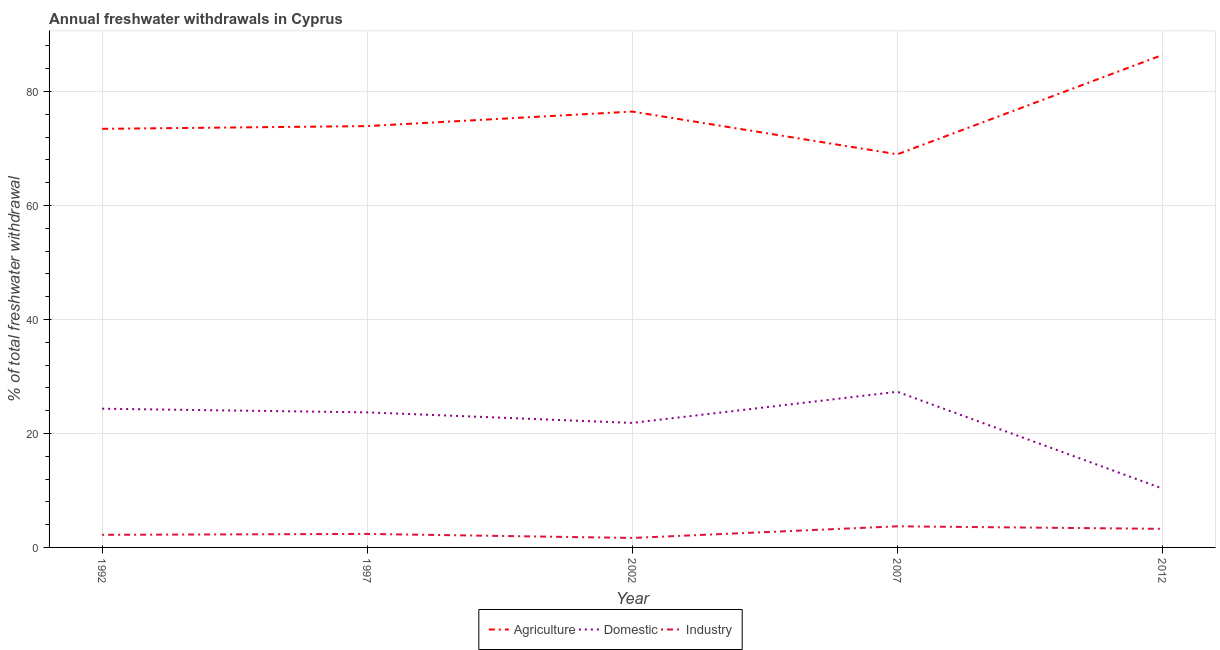How many different coloured lines are there?
Your answer should be very brief. 3. Does the line corresponding to percentage of freshwater withdrawal for domestic purposes intersect with the line corresponding to percentage of freshwater withdrawal for industry?
Give a very brief answer. No. Is the number of lines equal to the number of legend labels?
Your answer should be very brief. Yes. What is the percentage of freshwater withdrawal for industry in 2012?
Provide a short and direct response. 3.26. Across all years, what is the maximum percentage of freshwater withdrawal for domestic purposes?
Ensure brevity in your answer.  27.31. Across all years, what is the minimum percentage of freshwater withdrawal for industry?
Your answer should be very brief. 1.66. In which year was the percentage of freshwater withdrawal for domestic purposes maximum?
Your response must be concise. 2007. In which year was the percentage of freshwater withdrawal for industry minimum?
Make the answer very short. 2002. What is the total percentage of freshwater withdrawal for industry in the graph?
Your answer should be very brief. 13.21. What is the difference between the percentage of freshwater withdrawal for agriculture in 2007 and the percentage of freshwater withdrawal for industry in 2012?
Your answer should be very brief. 65.72. What is the average percentage of freshwater withdrawal for domestic purposes per year?
Provide a succinct answer. 21.51. In the year 1997, what is the difference between the percentage of freshwater withdrawal for agriculture and percentage of freshwater withdrawal for industry?
Offer a very short reply. 71.56. What is the ratio of the percentage of freshwater withdrawal for domestic purposes in 1997 to that in 2012?
Provide a succinct answer. 2.29. Is the percentage of freshwater withdrawal for agriculture in 1992 less than that in 2012?
Make the answer very short. Yes. Is the difference between the percentage of freshwater withdrawal for industry in 1997 and 2012 greater than the difference between the percentage of freshwater withdrawal for agriculture in 1997 and 2012?
Your answer should be very brief. Yes. What is the difference between the highest and the second highest percentage of freshwater withdrawal for industry?
Ensure brevity in your answer.  0.44. What is the difference between the highest and the lowest percentage of freshwater withdrawal for domestic purposes?
Your answer should be compact. 16.98. In how many years, is the percentage of freshwater withdrawal for domestic purposes greater than the average percentage of freshwater withdrawal for domestic purposes taken over all years?
Your response must be concise. 4. Does the percentage of freshwater withdrawal for industry monotonically increase over the years?
Provide a succinct answer. No. Is the percentage of freshwater withdrawal for domestic purposes strictly less than the percentage of freshwater withdrawal for agriculture over the years?
Your response must be concise. Yes. How many years are there in the graph?
Make the answer very short. 5. Are the values on the major ticks of Y-axis written in scientific E-notation?
Give a very brief answer. No. Does the graph contain grids?
Ensure brevity in your answer.  Yes. What is the title of the graph?
Give a very brief answer. Annual freshwater withdrawals in Cyprus. Does "Nuclear sources" appear as one of the legend labels in the graph?
Provide a succinct answer. No. What is the label or title of the X-axis?
Provide a short and direct response. Year. What is the label or title of the Y-axis?
Make the answer very short. % of total freshwater withdrawal. What is the % of total freshwater withdrawal of Agriculture in 1992?
Provide a short and direct response. 73.45. What is the % of total freshwater withdrawal of Domestic in 1992?
Your answer should be very brief. 24.34. What is the % of total freshwater withdrawal of Industry in 1992?
Your response must be concise. 2.21. What is the % of total freshwater withdrawal in Agriculture in 1997?
Give a very brief answer. 73.93. What is the % of total freshwater withdrawal in Domestic in 1997?
Your response must be concise. 23.7. What is the % of total freshwater withdrawal in Industry in 1997?
Make the answer very short. 2.37. What is the % of total freshwater withdrawal in Agriculture in 2002?
Provide a succinct answer. 76.48. What is the % of total freshwater withdrawal of Domestic in 2002?
Offer a terse response. 21.85. What is the % of total freshwater withdrawal in Industry in 2002?
Keep it short and to the point. 1.66. What is the % of total freshwater withdrawal in Agriculture in 2007?
Offer a very short reply. 68.98. What is the % of total freshwater withdrawal in Domestic in 2007?
Your answer should be very brief. 27.31. What is the % of total freshwater withdrawal of Industry in 2007?
Offer a terse response. 3.7. What is the % of total freshwater withdrawal in Agriculture in 2012?
Offer a very short reply. 86.41. What is the % of total freshwater withdrawal of Domestic in 2012?
Provide a short and direct response. 10.33. What is the % of total freshwater withdrawal in Industry in 2012?
Keep it short and to the point. 3.26. Across all years, what is the maximum % of total freshwater withdrawal in Agriculture?
Your response must be concise. 86.41. Across all years, what is the maximum % of total freshwater withdrawal in Domestic?
Your response must be concise. 27.31. Across all years, what is the maximum % of total freshwater withdrawal in Industry?
Ensure brevity in your answer.  3.7. Across all years, what is the minimum % of total freshwater withdrawal of Agriculture?
Your answer should be compact. 68.98. Across all years, what is the minimum % of total freshwater withdrawal of Domestic?
Make the answer very short. 10.33. Across all years, what is the minimum % of total freshwater withdrawal of Industry?
Provide a succinct answer. 1.66. What is the total % of total freshwater withdrawal in Agriculture in the graph?
Ensure brevity in your answer.  379.25. What is the total % of total freshwater withdrawal in Domestic in the graph?
Your answer should be very brief. 107.53. What is the total % of total freshwater withdrawal of Industry in the graph?
Give a very brief answer. 13.21. What is the difference between the % of total freshwater withdrawal of Agriculture in 1992 and that in 1997?
Make the answer very short. -0.48. What is the difference between the % of total freshwater withdrawal in Domestic in 1992 and that in 1997?
Your response must be concise. 0.64. What is the difference between the % of total freshwater withdrawal in Industry in 1992 and that in 1997?
Keep it short and to the point. -0.16. What is the difference between the % of total freshwater withdrawal in Agriculture in 1992 and that in 2002?
Offer a terse response. -3.03. What is the difference between the % of total freshwater withdrawal of Domestic in 1992 and that in 2002?
Ensure brevity in your answer.  2.49. What is the difference between the % of total freshwater withdrawal in Industry in 1992 and that in 2002?
Your response must be concise. 0.55. What is the difference between the % of total freshwater withdrawal in Agriculture in 1992 and that in 2007?
Provide a short and direct response. 4.47. What is the difference between the % of total freshwater withdrawal of Domestic in 1992 and that in 2007?
Provide a short and direct response. -2.97. What is the difference between the % of total freshwater withdrawal of Industry in 1992 and that in 2007?
Offer a terse response. -1.49. What is the difference between the % of total freshwater withdrawal in Agriculture in 1992 and that in 2012?
Make the answer very short. -12.96. What is the difference between the % of total freshwater withdrawal in Domestic in 1992 and that in 2012?
Provide a succinct answer. 14.01. What is the difference between the % of total freshwater withdrawal of Industry in 1992 and that in 2012?
Give a very brief answer. -1.05. What is the difference between the % of total freshwater withdrawal in Agriculture in 1997 and that in 2002?
Ensure brevity in your answer.  -2.55. What is the difference between the % of total freshwater withdrawal of Domestic in 1997 and that in 2002?
Offer a terse response. 1.85. What is the difference between the % of total freshwater withdrawal of Industry in 1997 and that in 2002?
Provide a short and direct response. 0.71. What is the difference between the % of total freshwater withdrawal in Agriculture in 1997 and that in 2007?
Give a very brief answer. 4.95. What is the difference between the % of total freshwater withdrawal of Domestic in 1997 and that in 2007?
Your answer should be very brief. -3.61. What is the difference between the % of total freshwater withdrawal in Industry in 1997 and that in 2007?
Make the answer very short. -1.33. What is the difference between the % of total freshwater withdrawal of Agriculture in 1997 and that in 2012?
Give a very brief answer. -12.48. What is the difference between the % of total freshwater withdrawal of Domestic in 1997 and that in 2012?
Your response must be concise. 13.37. What is the difference between the % of total freshwater withdrawal of Industry in 1997 and that in 2012?
Make the answer very short. -0.89. What is the difference between the % of total freshwater withdrawal in Agriculture in 2002 and that in 2007?
Your answer should be very brief. 7.5. What is the difference between the % of total freshwater withdrawal in Domestic in 2002 and that in 2007?
Provide a short and direct response. -5.46. What is the difference between the % of total freshwater withdrawal of Industry in 2002 and that in 2007?
Your response must be concise. -2.04. What is the difference between the % of total freshwater withdrawal of Agriculture in 2002 and that in 2012?
Your answer should be very brief. -9.93. What is the difference between the % of total freshwater withdrawal in Domestic in 2002 and that in 2012?
Ensure brevity in your answer.  11.52. What is the difference between the % of total freshwater withdrawal of Industry in 2002 and that in 2012?
Your response must be concise. -1.6. What is the difference between the % of total freshwater withdrawal of Agriculture in 2007 and that in 2012?
Ensure brevity in your answer.  -17.43. What is the difference between the % of total freshwater withdrawal of Domestic in 2007 and that in 2012?
Keep it short and to the point. 16.98. What is the difference between the % of total freshwater withdrawal in Industry in 2007 and that in 2012?
Provide a short and direct response. 0.44. What is the difference between the % of total freshwater withdrawal of Agriculture in 1992 and the % of total freshwater withdrawal of Domestic in 1997?
Make the answer very short. 49.75. What is the difference between the % of total freshwater withdrawal of Agriculture in 1992 and the % of total freshwater withdrawal of Industry in 1997?
Your response must be concise. 71.08. What is the difference between the % of total freshwater withdrawal of Domestic in 1992 and the % of total freshwater withdrawal of Industry in 1997?
Provide a succinct answer. 21.97. What is the difference between the % of total freshwater withdrawal of Agriculture in 1992 and the % of total freshwater withdrawal of Domestic in 2002?
Give a very brief answer. 51.6. What is the difference between the % of total freshwater withdrawal in Agriculture in 1992 and the % of total freshwater withdrawal in Industry in 2002?
Your answer should be compact. 71.79. What is the difference between the % of total freshwater withdrawal in Domestic in 1992 and the % of total freshwater withdrawal in Industry in 2002?
Your response must be concise. 22.68. What is the difference between the % of total freshwater withdrawal in Agriculture in 1992 and the % of total freshwater withdrawal in Domestic in 2007?
Keep it short and to the point. 46.14. What is the difference between the % of total freshwater withdrawal in Agriculture in 1992 and the % of total freshwater withdrawal in Industry in 2007?
Keep it short and to the point. 69.75. What is the difference between the % of total freshwater withdrawal in Domestic in 1992 and the % of total freshwater withdrawal in Industry in 2007?
Offer a very short reply. 20.64. What is the difference between the % of total freshwater withdrawal in Agriculture in 1992 and the % of total freshwater withdrawal in Domestic in 2012?
Provide a short and direct response. 63.12. What is the difference between the % of total freshwater withdrawal of Agriculture in 1992 and the % of total freshwater withdrawal of Industry in 2012?
Your answer should be compact. 70.19. What is the difference between the % of total freshwater withdrawal of Domestic in 1992 and the % of total freshwater withdrawal of Industry in 2012?
Ensure brevity in your answer.  21.08. What is the difference between the % of total freshwater withdrawal in Agriculture in 1997 and the % of total freshwater withdrawal in Domestic in 2002?
Your answer should be compact. 52.08. What is the difference between the % of total freshwater withdrawal in Agriculture in 1997 and the % of total freshwater withdrawal in Industry in 2002?
Provide a succinct answer. 72.27. What is the difference between the % of total freshwater withdrawal of Domestic in 1997 and the % of total freshwater withdrawal of Industry in 2002?
Make the answer very short. 22.04. What is the difference between the % of total freshwater withdrawal of Agriculture in 1997 and the % of total freshwater withdrawal of Domestic in 2007?
Provide a succinct answer. 46.62. What is the difference between the % of total freshwater withdrawal of Agriculture in 1997 and the % of total freshwater withdrawal of Industry in 2007?
Ensure brevity in your answer.  70.23. What is the difference between the % of total freshwater withdrawal of Domestic in 1997 and the % of total freshwater withdrawal of Industry in 2007?
Offer a terse response. 20. What is the difference between the % of total freshwater withdrawal of Agriculture in 1997 and the % of total freshwater withdrawal of Domestic in 2012?
Provide a short and direct response. 63.6. What is the difference between the % of total freshwater withdrawal of Agriculture in 1997 and the % of total freshwater withdrawal of Industry in 2012?
Your answer should be compact. 70.67. What is the difference between the % of total freshwater withdrawal of Domestic in 1997 and the % of total freshwater withdrawal of Industry in 2012?
Offer a very short reply. 20.44. What is the difference between the % of total freshwater withdrawal of Agriculture in 2002 and the % of total freshwater withdrawal of Domestic in 2007?
Provide a short and direct response. 49.17. What is the difference between the % of total freshwater withdrawal of Agriculture in 2002 and the % of total freshwater withdrawal of Industry in 2007?
Your answer should be compact. 72.78. What is the difference between the % of total freshwater withdrawal in Domestic in 2002 and the % of total freshwater withdrawal in Industry in 2007?
Offer a very short reply. 18.15. What is the difference between the % of total freshwater withdrawal in Agriculture in 2002 and the % of total freshwater withdrawal in Domestic in 2012?
Provide a succinct answer. 66.15. What is the difference between the % of total freshwater withdrawal of Agriculture in 2002 and the % of total freshwater withdrawal of Industry in 2012?
Ensure brevity in your answer.  73.22. What is the difference between the % of total freshwater withdrawal in Domestic in 2002 and the % of total freshwater withdrawal in Industry in 2012?
Offer a terse response. 18.59. What is the difference between the % of total freshwater withdrawal of Agriculture in 2007 and the % of total freshwater withdrawal of Domestic in 2012?
Provide a short and direct response. 58.65. What is the difference between the % of total freshwater withdrawal of Agriculture in 2007 and the % of total freshwater withdrawal of Industry in 2012?
Offer a terse response. 65.72. What is the difference between the % of total freshwater withdrawal in Domestic in 2007 and the % of total freshwater withdrawal in Industry in 2012?
Ensure brevity in your answer.  24.05. What is the average % of total freshwater withdrawal of Agriculture per year?
Provide a succinct answer. 75.85. What is the average % of total freshwater withdrawal in Domestic per year?
Keep it short and to the point. 21.51. What is the average % of total freshwater withdrawal of Industry per year?
Make the answer very short. 2.64. In the year 1992, what is the difference between the % of total freshwater withdrawal of Agriculture and % of total freshwater withdrawal of Domestic?
Offer a terse response. 49.11. In the year 1992, what is the difference between the % of total freshwater withdrawal in Agriculture and % of total freshwater withdrawal in Industry?
Offer a terse response. 71.24. In the year 1992, what is the difference between the % of total freshwater withdrawal in Domestic and % of total freshwater withdrawal in Industry?
Make the answer very short. 22.13. In the year 1997, what is the difference between the % of total freshwater withdrawal in Agriculture and % of total freshwater withdrawal in Domestic?
Provide a succinct answer. 50.23. In the year 1997, what is the difference between the % of total freshwater withdrawal in Agriculture and % of total freshwater withdrawal in Industry?
Your answer should be compact. 71.56. In the year 1997, what is the difference between the % of total freshwater withdrawal in Domestic and % of total freshwater withdrawal in Industry?
Your answer should be very brief. 21.33. In the year 2002, what is the difference between the % of total freshwater withdrawal of Agriculture and % of total freshwater withdrawal of Domestic?
Your answer should be very brief. 54.63. In the year 2002, what is the difference between the % of total freshwater withdrawal of Agriculture and % of total freshwater withdrawal of Industry?
Your answer should be very brief. 74.82. In the year 2002, what is the difference between the % of total freshwater withdrawal of Domestic and % of total freshwater withdrawal of Industry?
Make the answer very short. 20.19. In the year 2007, what is the difference between the % of total freshwater withdrawal of Agriculture and % of total freshwater withdrawal of Domestic?
Your answer should be very brief. 41.67. In the year 2007, what is the difference between the % of total freshwater withdrawal in Agriculture and % of total freshwater withdrawal in Industry?
Provide a succinct answer. 65.28. In the year 2007, what is the difference between the % of total freshwater withdrawal of Domestic and % of total freshwater withdrawal of Industry?
Offer a very short reply. 23.61. In the year 2012, what is the difference between the % of total freshwater withdrawal of Agriculture and % of total freshwater withdrawal of Domestic?
Provide a short and direct response. 76.08. In the year 2012, what is the difference between the % of total freshwater withdrawal of Agriculture and % of total freshwater withdrawal of Industry?
Make the answer very short. 83.15. In the year 2012, what is the difference between the % of total freshwater withdrawal in Domestic and % of total freshwater withdrawal in Industry?
Your answer should be very brief. 7.07. What is the ratio of the % of total freshwater withdrawal of Agriculture in 1992 to that in 1997?
Give a very brief answer. 0.99. What is the ratio of the % of total freshwater withdrawal of Domestic in 1992 to that in 1997?
Your answer should be compact. 1.03. What is the ratio of the % of total freshwater withdrawal in Agriculture in 1992 to that in 2002?
Provide a short and direct response. 0.96. What is the ratio of the % of total freshwater withdrawal in Domestic in 1992 to that in 2002?
Give a very brief answer. 1.11. What is the ratio of the % of total freshwater withdrawal of Industry in 1992 to that in 2002?
Make the answer very short. 1.33. What is the ratio of the % of total freshwater withdrawal in Agriculture in 1992 to that in 2007?
Your answer should be compact. 1.06. What is the ratio of the % of total freshwater withdrawal in Domestic in 1992 to that in 2007?
Make the answer very short. 0.89. What is the ratio of the % of total freshwater withdrawal in Industry in 1992 to that in 2007?
Keep it short and to the point. 0.6. What is the ratio of the % of total freshwater withdrawal in Domestic in 1992 to that in 2012?
Ensure brevity in your answer.  2.36. What is the ratio of the % of total freshwater withdrawal of Industry in 1992 to that in 2012?
Give a very brief answer. 0.68. What is the ratio of the % of total freshwater withdrawal of Agriculture in 1997 to that in 2002?
Your answer should be very brief. 0.97. What is the ratio of the % of total freshwater withdrawal of Domestic in 1997 to that in 2002?
Your answer should be compact. 1.08. What is the ratio of the % of total freshwater withdrawal of Industry in 1997 to that in 2002?
Your answer should be very brief. 1.43. What is the ratio of the % of total freshwater withdrawal of Agriculture in 1997 to that in 2007?
Make the answer very short. 1.07. What is the ratio of the % of total freshwater withdrawal of Domestic in 1997 to that in 2007?
Ensure brevity in your answer.  0.87. What is the ratio of the % of total freshwater withdrawal in Industry in 1997 to that in 2007?
Provide a succinct answer. 0.64. What is the ratio of the % of total freshwater withdrawal of Agriculture in 1997 to that in 2012?
Your answer should be compact. 0.86. What is the ratio of the % of total freshwater withdrawal of Domestic in 1997 to that in 2012?
Offer a terse response. 2.29. What is the ratio of the % of total freshwater withdrawal in Industry in 1997 to that in 2012?
Ensure brevity in your answer.  0.73. What is the ratio of the % of total freshwater withdrawal of Agriculture in 2002 to that in 2007?
Your answer should be very brief. 1.11. What is the ratio of the % of total freshwater withdrawal of Domestic in 2002 to that in 2007?
Ensure brevity in your answer.  0.8. What is the ratio of the % of total freshwater withdrawal of Industry in 2002 to that in 2007?
Provide a short and direct response. 0.45. What is the ratio of the % of total freshwater withdrawal of Agriculture in 2002 to that in 2012?
Your answer should be very brief. 0.89. What is the ratio of the % of total freshwater withdrawal in Domestic in 2002 to that in 2012?
Provide a short and direct response. 2.12. What is the ratio of the % of total freshwater withdrawal in Industry in 2002 to that in 2012?
Give a very brief answer. 0.51. What is the ratio of the % of total freshwater withdrawal in Agriculture in 2007 to that in 2012?
Ensure brevity in your answer.  0.8. What is the ratio of the % of total freshwater withdrawal of Domestic in 2007 to that in 2012?
Keep it short and to the point. 2.64. What is the ratio of the % of total freshwater withdrawal in Industry in 2007 to that in 2012?
Your answer should be very brief. 1.14. What is the difference between the highest and the second highest % of total freshwater withdrawal in Agriculture?
Provide a short and direct response. 9.93. What is the difference between the highest and the second highest % of total freshwater withdrawal of Domestic?
Your answer should be very brief. 2.97. What is the difference between the highest and the second highest % of total freshwater withdrawal of Industry?
Give a very brief answer. 0.44. What is the difference between the highest and the lowest % of total freshwater withdrawal of Agriculture?
Ensure brevity in your answer.  17.43. What is the difference between the highest and the lowest % of total freshwater withdrawal of Domestic?
Your response must be concise. 16.98. What is the difference between the highest and the lowest % of total freshwater withdrawal in Industry?
Ensure brevity in your answer.  2.04. 